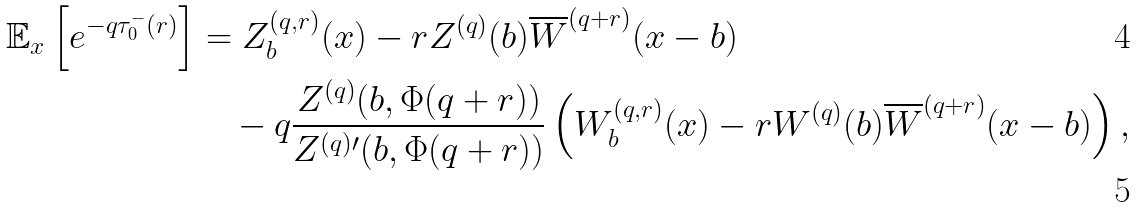Convert formula to latex. <formula><loc_0><loc_0><loc_500><loc_500>\mathbb { E } _ { x } \left [ e ^ { - q \tau _ { 0 } ^ { - } ( r ) } \right ] & = Z _ { b } ^ { ( q , r ) } ( x ) - r Z ^ { ( q ) } ( b ) \overline { W } ^ { ( q + r ) } ( x - b ) \\ & \quad - q \frac { Z ^ { ( q ) } ( b , \Phi ( q + r ) ) } { Z ^ { ( q ) \prime } ( b , \Phi ( q + r ) ) } \left ( W _ { b } ^ { ( q , r ) } ( x ) - r W ^ { ( q ) } ( b ) \overline { W } ^ { ( q + r ) } ( x - b ) \right ) ,</formula> 